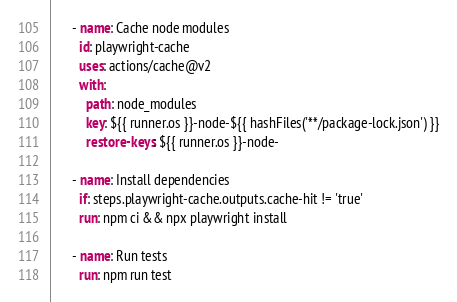<code> <loc_0><loc_0><loc_500><loc_500><_YAML_>
      - name: Cache node modules
        id: playwright-cache
        uses: actions/cache@v2
        with:
          path: node_modules
          key: ${{ runner.os }}-node-${{ hashFiles('**/package-lock.json') }}
          restore-keys: ${{ runner.os }}-node-

      - name: Install dependencies
        if: steps.playwright-cache.outputs.cache-hit != 'true'
        run: npm ci && npx playwright install

      - name: Run tests
        run: npm run test
</code> 